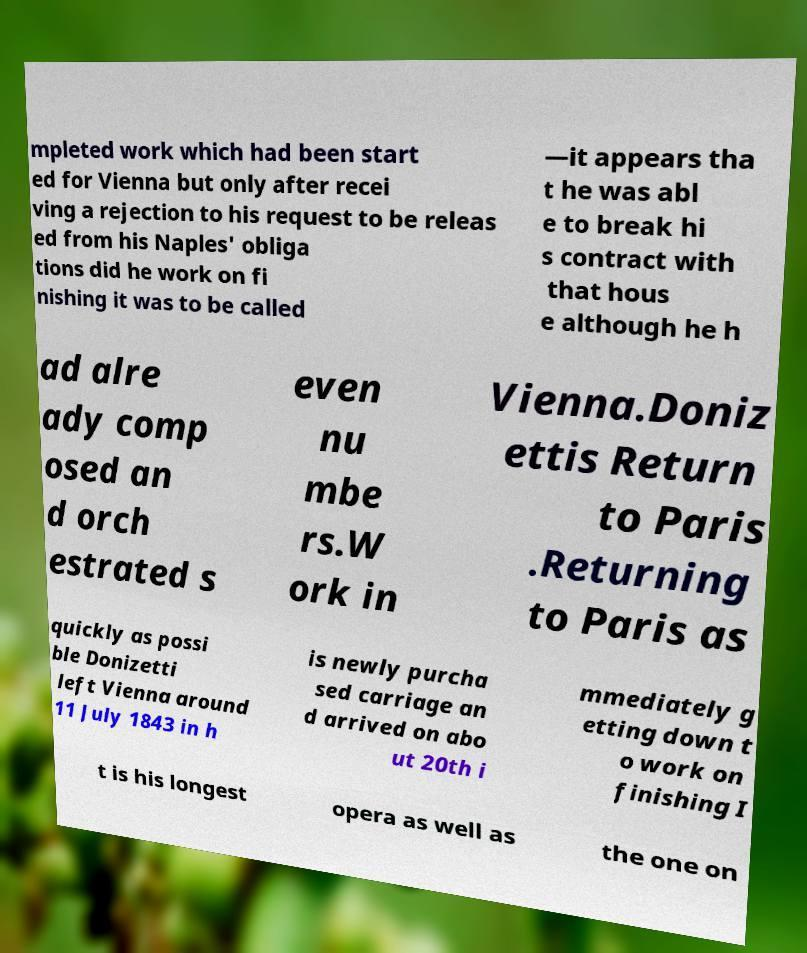There's text embedded in this image that I need extracted. Can you transcribe it verbatim? mpleted work which had been start ed for Vienna but only after recei ving a rejection to his request to be releas ed from his Naples' obliga tions did he work on fi nishing it was to be called —it appears tha t he was abl e to break hi s contract with that hous e although he h ad alre ady comp osed an d orch estrated s even nu mbe rs.W ork in Vienna.Doniz ettis Return to Paris .Returning to Paris as quickly as possi ble Donizetti left Vienna around 11 July 1843 in h is newly purcha sed carriage an d arrived on abo ut 20th i mmediately g etting down t o work on finishing I t is his longest opera as well as the one on 